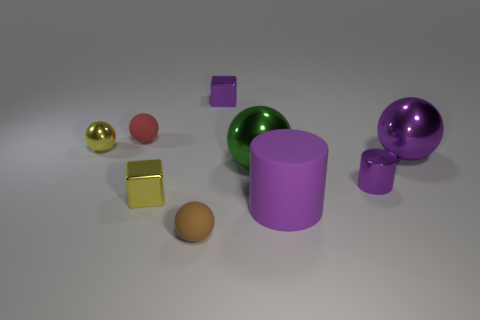Add 1 gray matte cubes. How many objects exist? 10 Subtract all small brown matte balls. How many balls are left? 4 Subtract 2 blocks. How many blocks are left? 0 Subtract all cylinders. How many objects are left? 7 Subtract all red balls. How many balls are left? 4 Add 6 tiny yellow things. How many tiny yellow things are left? 8 Add 9 brown matte spheres. How many brown matte spheres exist? 10 Subtract 1 yellow cubes. How many objects are left? 8 Subtract all yellow cubes. Subtract all yellow spheres. How many cubes are left? 1 Subtract all blue balls. How many purple cubes are left? 1 